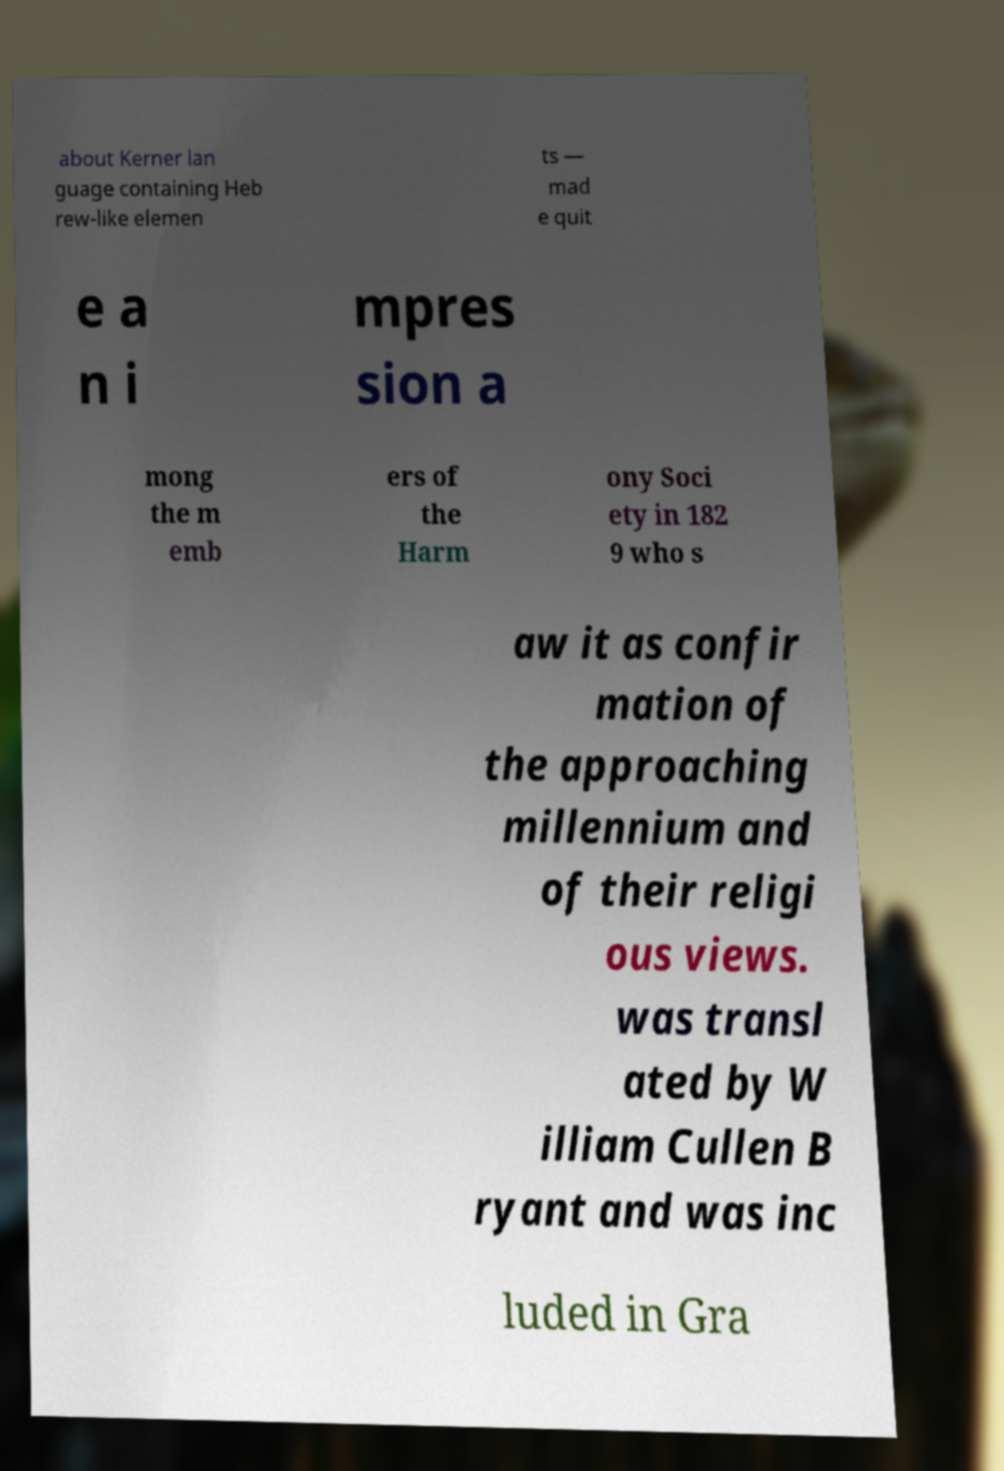There's text embedded in this image that I need extracted. Can you transcribe it verbatim? about Kerner lan guage containing Heb rew-like elemen ts — mad e quit e a n i mpres sion a mong the m emb ers of the Harm ony Soci ety in 182 9 who s aw it as confir mation of the approaching millennium and of their religi ous views. was transl ated by W illiam Cullen B ryant and was inc luded in Gra 